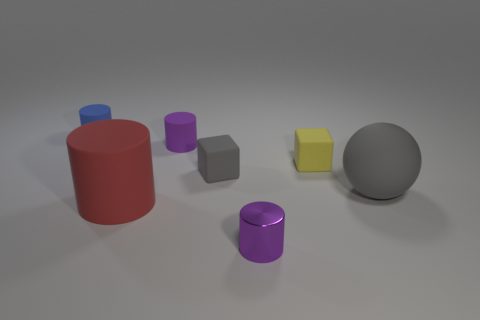Is there any other thing that has the same material as the small yellow cube?
Provide a short and direct response. Yes. There is a rubber object that is the same color as the shiny cylinder; what shape is it?
Give a very brief answer. Cylinder. How many green objects are small cylinders or large spheres?
Provide a short and direct response. 0. There is a purple metal object; are there any small matte things left of it?
Provide a short and direct response. Yes. What is the size of the blue cylinder?
Give a very brief answer. Small. What size is the red rubber object that is the same shape as the small metallic object?
Ensure brevity in your answer.  Large. There is a small purple cylinder that is in front of the big gray rubber thing; what number of cubes are right of it?
Keep it short and to the point. 1. Are the small purple cylinder that is behind the large matte cylinder and the purple cylinder in front of the big cylinder made of the same material?
Make the answer very short. No. What number of tiny yellow rubber things have the same shape as the small gray thing?
Provide a succinct answer. 1. What number of tiny rubber blocks are the same color as the large sphere?
Your answer should be very brief. 1. 